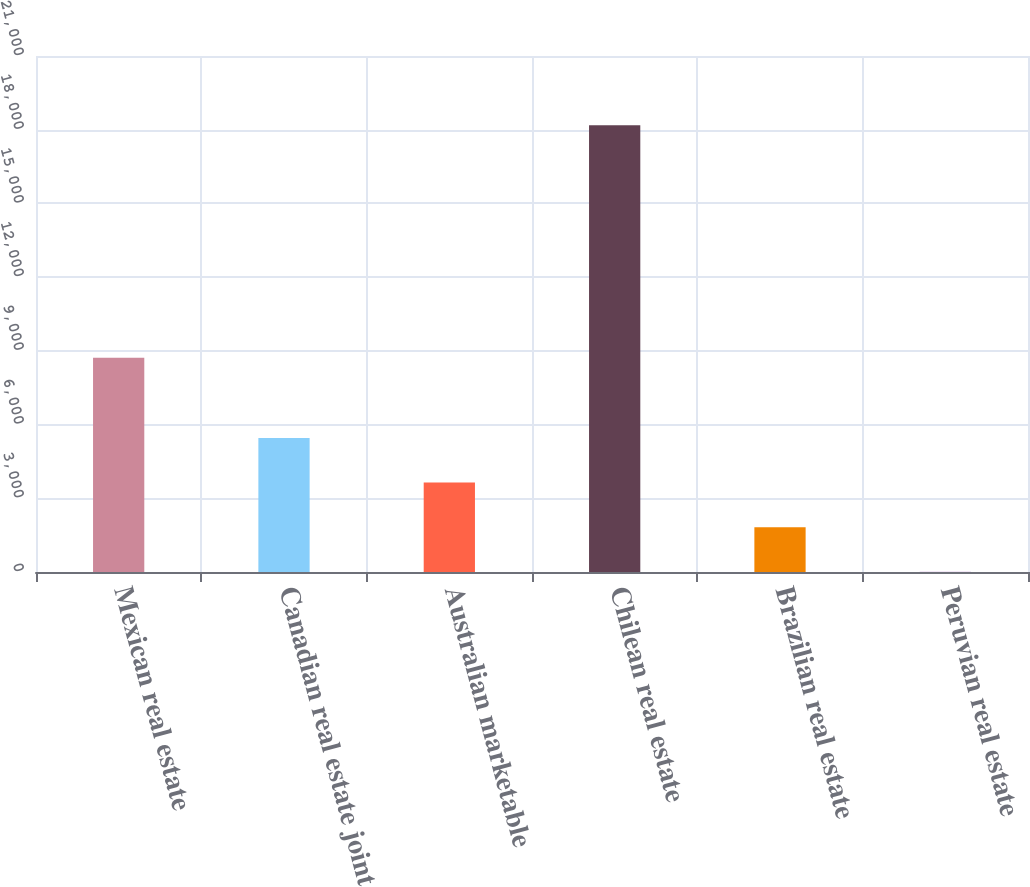<chart> <loc_0><loc_0><loc_500><loc_500><bar_chart><fcel>Mexican real estate<fcel>Canadian real estate joint<fcel>Australian marketable<fcel>Chilean real estate<fcel>Brazilian real estate<fcel>Peruvian real estate<nl><fcel>8715<fcel>5458.4<fcel>3641.3<fcel>18178.1<fcel>1824.2<fcel>7.1<nl></chart> 